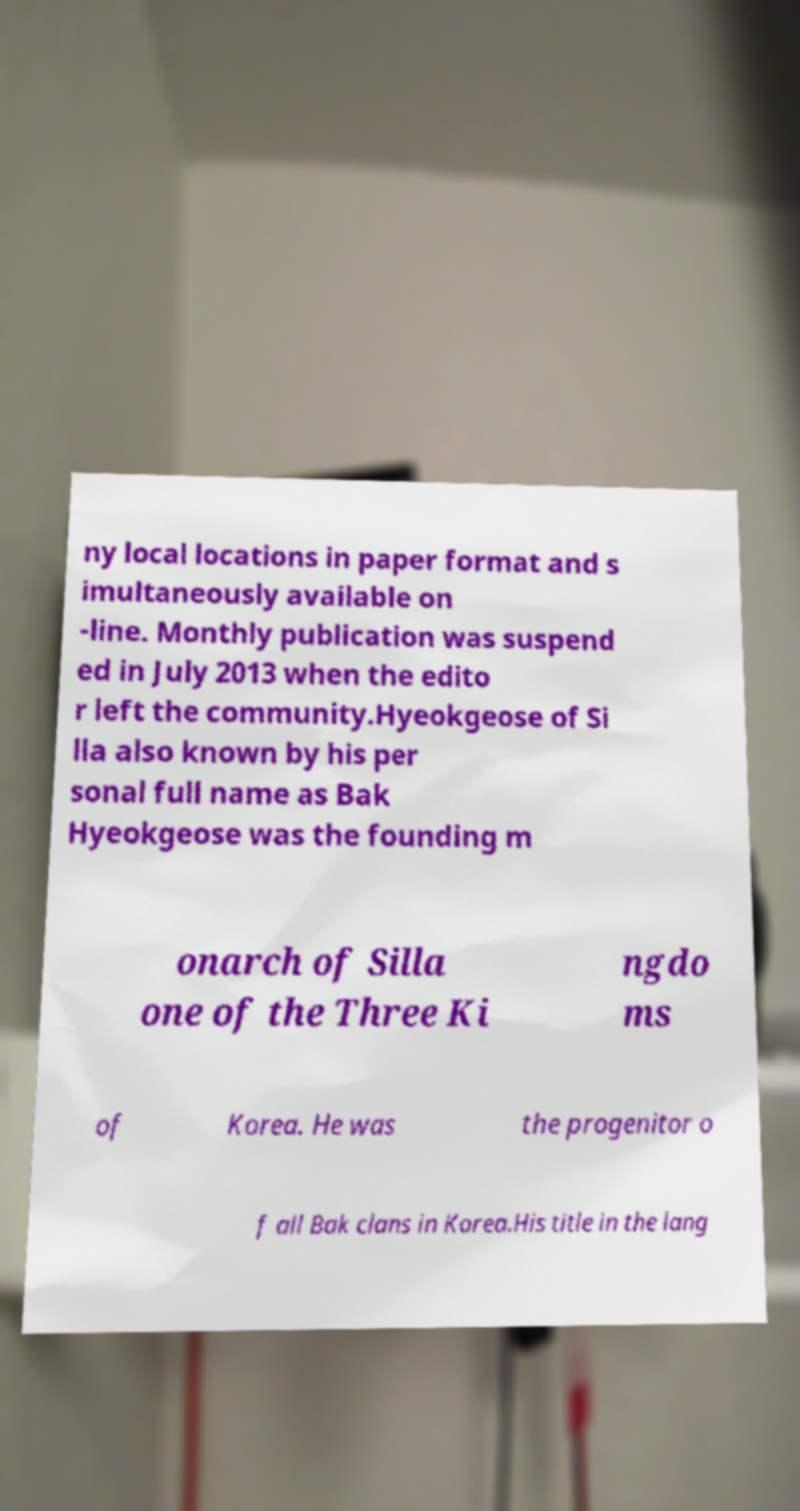Can you accurately transcribe the text from the provided image for me? ny local locations in paper format and s imultaneously available on -line. Monthly publication was suspend ed in July 2013 when the edito r left the community.Hyeokgeose of Si lla also known by his per sonal full name as Bak Hyeokgeose was the founding m onarch of Silla one of the Three Ki ngdo ms of Korea. He was the progenitor o f all Bak clans in Korea.His title in the lang 